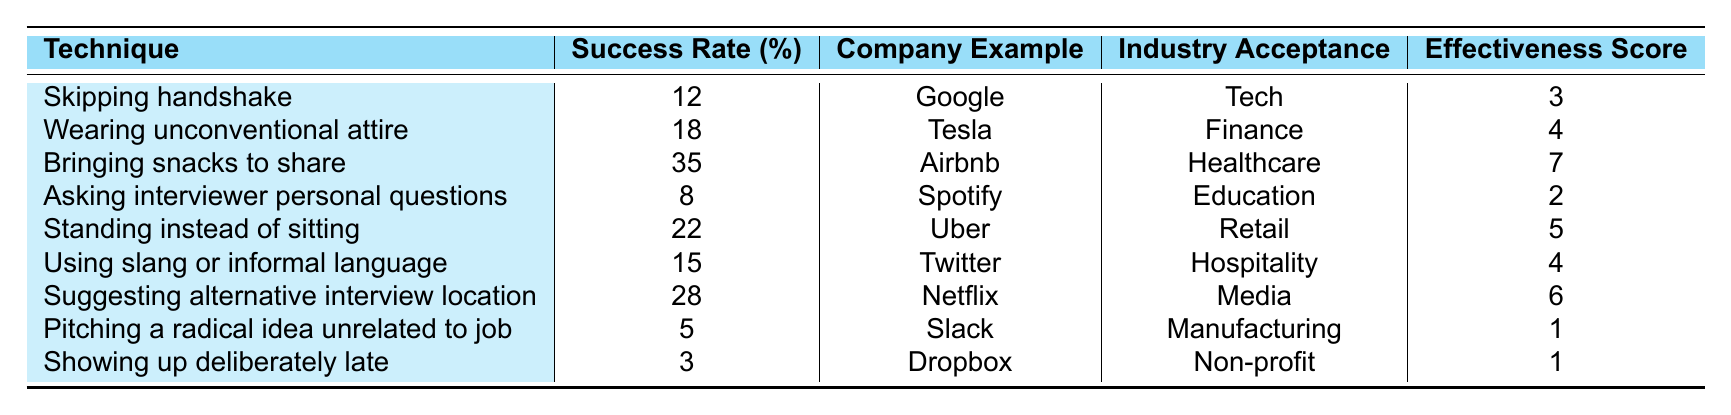What is the success rate of "Bringing snacks to share"? The success rate for "Bringing snacks to share" is provided directly in the table under the "Success Rate (%)" column. Looking at the corresponding row for this technique, the success rate is 35%.
Answer: 35% Which technique has the highest effectiveness score? To find the technique with the highest effectiveness score, we look at the "Effectiveness Score" column and identify the maximum value. The maximum score is 7, corresponding to "Bringing snacks to share."
Answer: Bringing snacks to share Is it true that "Showing up deliberately late" has a success rate greater than 5%? According to the table, the success rate of "Showing up deliberately late" is 3%, which is clearly less than 5%. Thus, the statement is false.
Answer: No What is the average success rate of all techniques listed? To find the average success rate, we sum all success rates: (12 + 18 + 35 + 8 + 22 + 15 + 28 + 5 + 3) = 148. There are 9 techniques, so we divide 148 by 9, which equals approximately 16.44.
Answer: 16.44 Which technique has the lowest success rate, and what is that rate? By examining the "Success Rate (%)" column, the lowest value is 3%, which corresponds to the technique "Showing up deliberately late."
Answer: Showing up deliberately late, 3% If you wanted to categorize techniques based on their success rates, how many have rates higher than 20%? We examine the success rates and count: "Bringing snacks to share" (35%), "Standing instead of sitting" (22%), and "Suggesting alternative interview location" (28%). Thus, there are 3 techniques with rates higher than 20%.
Answer: 3 What are the industry acceptances for techniques with an effectiveness score of 6 or higher? Reviewing the techniques with an effectiveness score of 6 or higher, we find that "Bringing snacks to share" (Healthcare) and "Suggesting alternative interview location" (Media) fit this criterion. Thus, the corresponding industries are Healthcare and Media.
Answer: Healthcare, Media Is "Wearing unconventional attire" more successful than "Using slang or informal language"? Comparing the success rates, "Wearing unconventional attire" has a rate of 18%, while "Using slang or informal language" has a rate of 15%. Since 18% is greater than 15%, the statement is true.
Answer: Yes How does the success rate of "Asking interviewer personal questions" compare to the average success rate? The success rate for "Asking interviewer personal questions" is 8%. From a previous calculation, the average success rate is approximately 16.44%. Since 8% is less than 16.44%, we conclude that it is lower.
Answer: Lower What is the total effectiveness score for all techniques listed? To calculate the total effectiveness score, we sum all effectiveness scores: (3 + 4 + 7 + 2 + 5 + 4 + 6 + 1 + 1) = 33.
Answer: 33 Which technique is used by the company "Dropbox"? According to the table, the technique used by Dropbox is "Showing up deliberately late."
Answer: Showing up deliberately late 